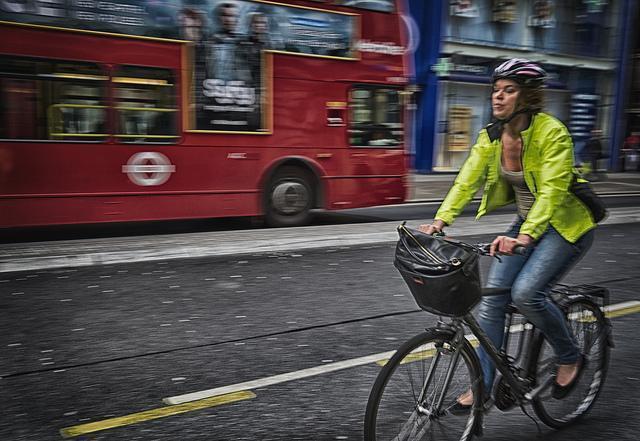What allows the woman on the bike to carry needed items safely?
From the following four choices, select the correct answer to address the question.
Options: Zip ties, red wagon, basket, bike rack. Basket. 